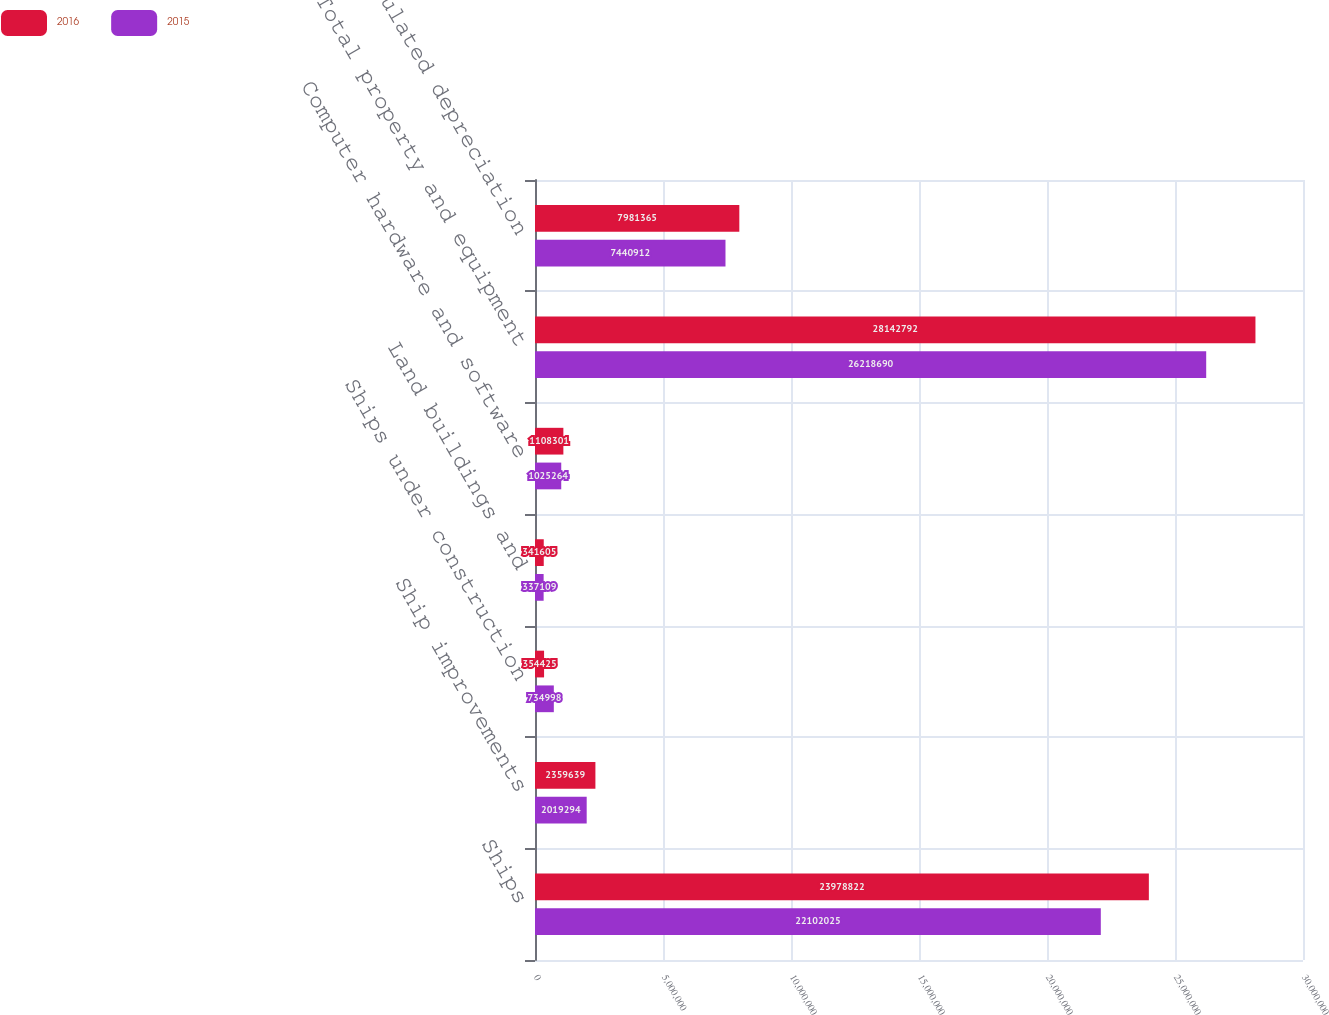Convert chart. <chart><loc_0><loc_0><loc_500><loc_500><stacked_bar_chart><ecel><fcel>Ships<fcel>Ship improvements<fcel>Ships under construction<fcel>Land buildings and<fcel>Computer hardware and software<fcel>Total property and equipment<fcel>Less-accumulated depreciation<nl><fcel>2016<fcel>2.39788e+07<fcel>2.35964e+06<fcel>354425<fcel>341605<fcel>1.1083e+06<fcel>2.81428e+07<fcel>7.98136e+06<nl><fcel>2015<fcel>2.2102e+07<fcel>2.01929e+06<fcel>734998<fcel>337109<fcel>1.02526e+06<fcel>2.62187e+07<fcel>7.44091e+06<nl></chart> 